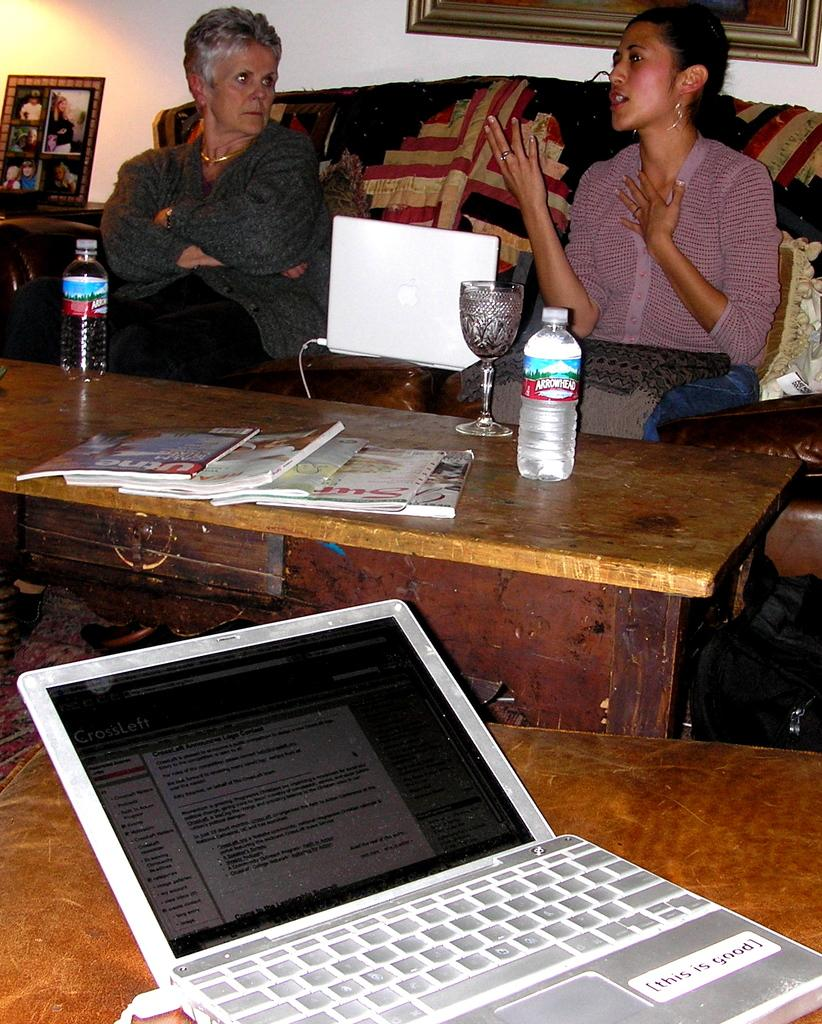How many women are seated in the image? There are two women seated on chairs in the image. What objects can be seen on the table? There is a bottle, a glass, books, and a laptop on the table. Is there anything else visible in the background? Yes, there is a photo frame in the background. Can you see any fog or frogs in the image? No, there is no fog or frogs present in the image. Is there any quicksand visible in the image? No, there is no quicksand visible in the image. 